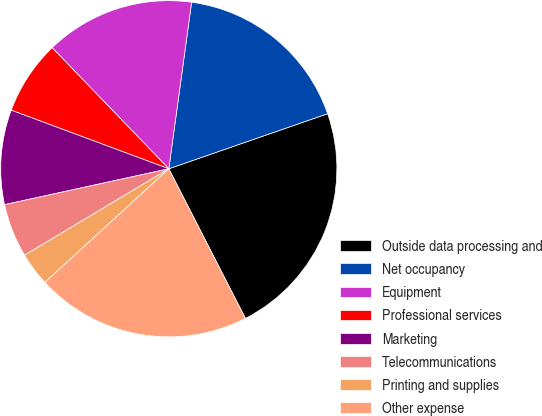Convert chart to OTSL. <chart><loc_0><loc_0><loc_500><loc_500><pie_chart><fcel>Outside data processing and<fcel>Net occupancy<fcel>Equipment<fcel>Professional services<fcel>Marketing<fcel>Telecommunications<fcel>Printing and supplies<fcel>Other expense<nl><fcel>22.78%<fcel>17.52%<fcel>14.37%<fcel>7.13%<fcel>9.09%<fcel>5.17%<fcel>3.22%<fcel>20.72%<nl></chart> 